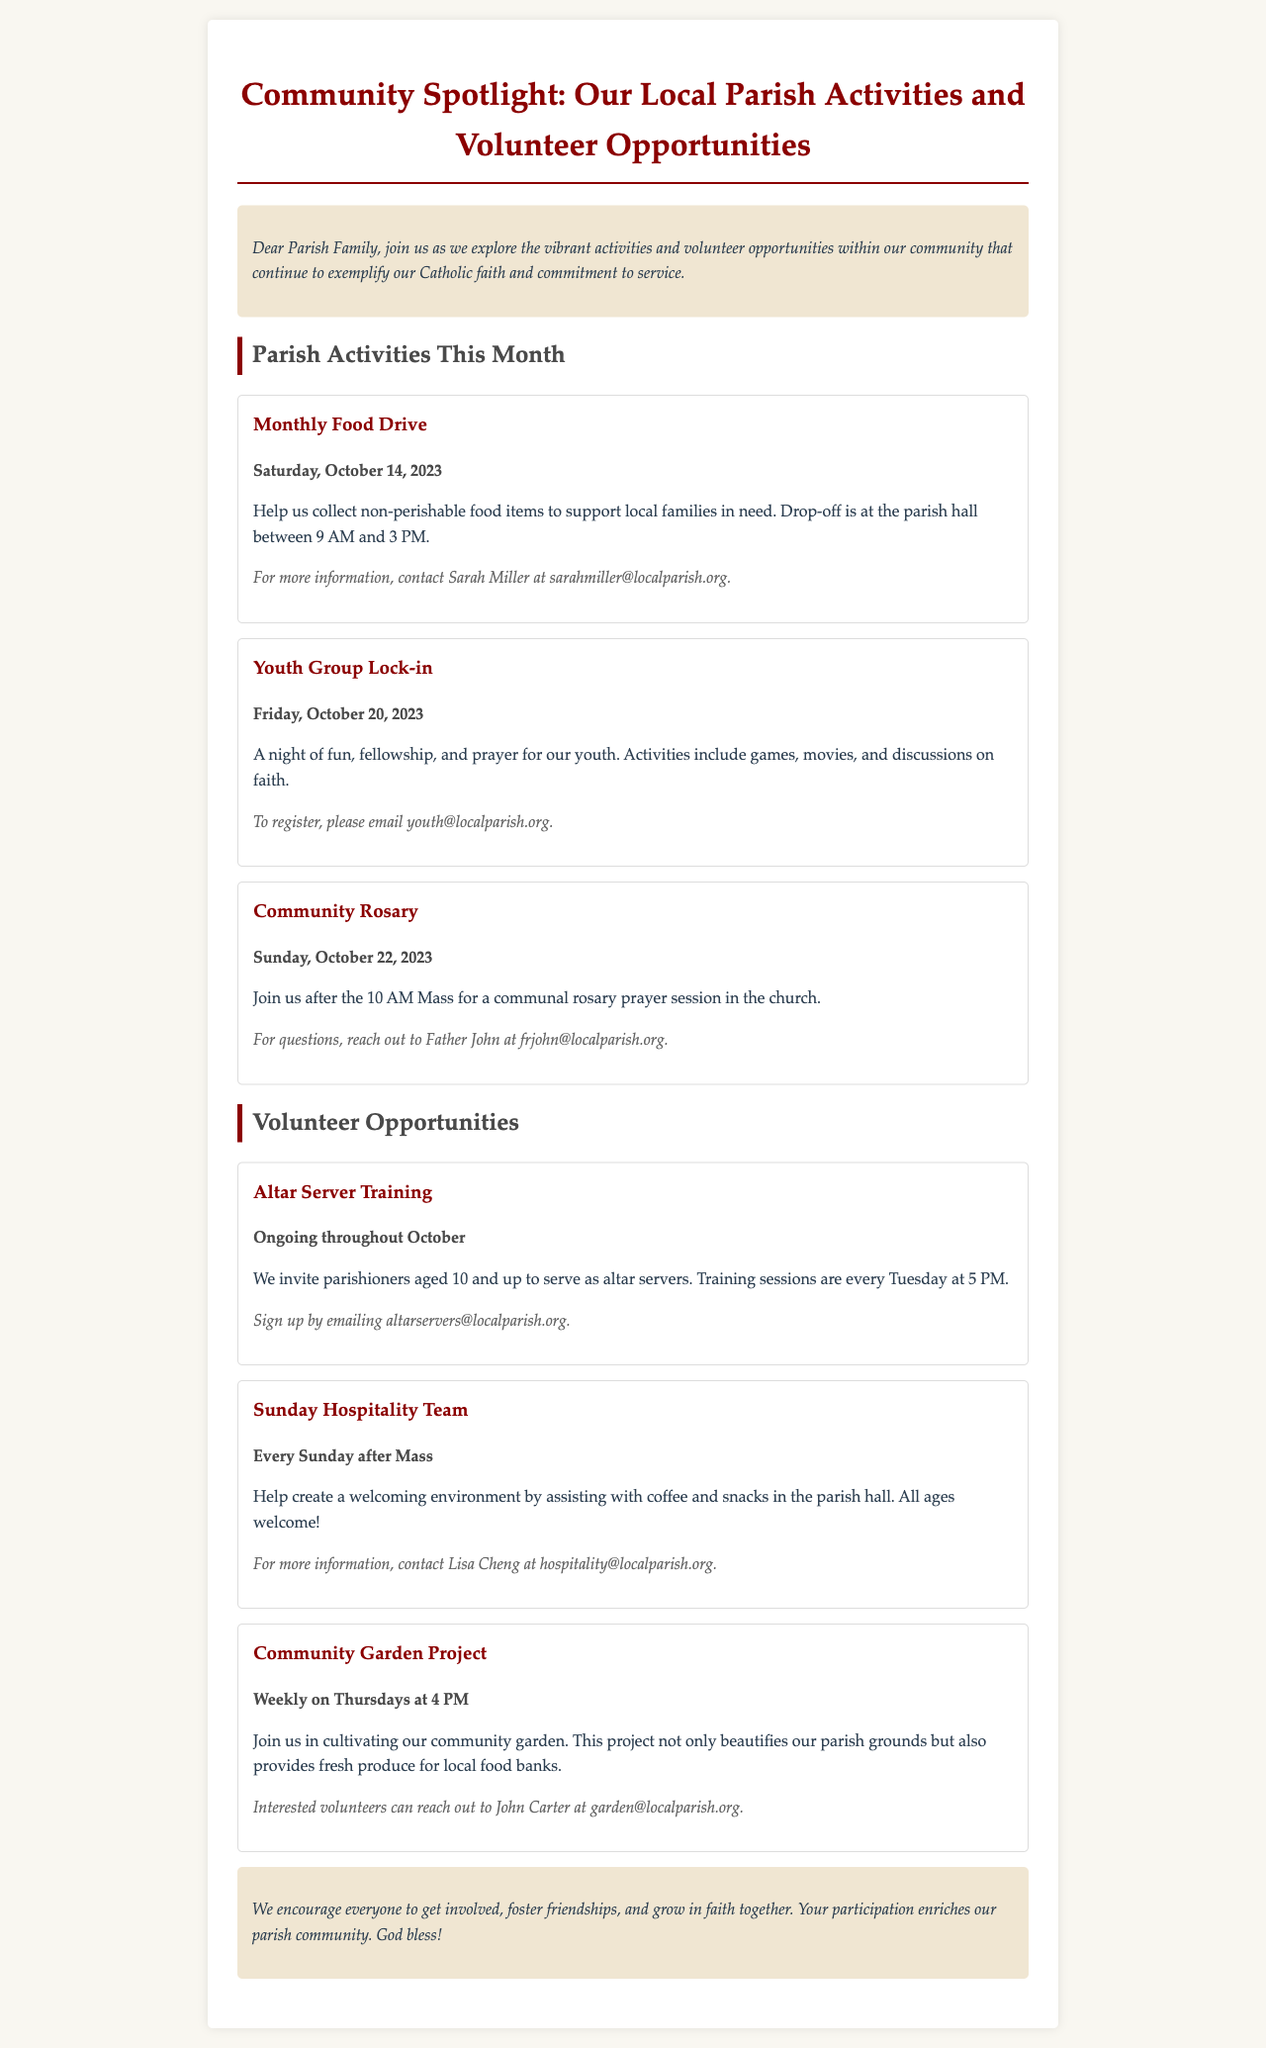What is the date of the Monthly Food Drive? The date provided in the document for the Monthly Food Drive is Saturday, October 14, 2023.
Answer: Saturday, October 14, 2023 Who is the contact person for the Youth Group Lock-in? The document states that to register for the Youth Group Lock-in, the contact person is the youth email provided.
Answer: youth@localparish.org What activity follows the 10 AM Mass on October 22, 2023? The document mentions that after the 10 AM Mass on October 22, 2023, there is a Community Rosary session.
Answer: Community Rosary How often does the Altar Server Training occur? According to the document, training sessions for altar servers occur every Tuesday throughout October.
Answer: Every Tuesday What is the age requirement for the Altar Server Training? The document specifies that parishioners aged 10 and up are invited to serve as altar servers.
Answer: 10 and up Which volunteer opportunity happens weekly on Thursdays? The document lists the Community Garden Project as the volunteer opportunity that occurs weekly on Thursdays.
Answer: Community Garden Project What is the goal of the Community Garden Project? The Community Garden Project aims to beautify the parish grounds and provide fresh produce for local food banks.
Answer: Beautify parish grounds and provide fresh produce What activity is described as suitable for all ages? The Sunday Hospitality Team is mentioned in the document as an opportunity suitable for all ages.
Answer: Sunday Hospitality Team What does the conclusion of the newsletter emphasize? The conclusion encourages everyone to participate, foster friendships, and grow in faith together, enriching the parish community.
Answer: Participation and growth in faith together 